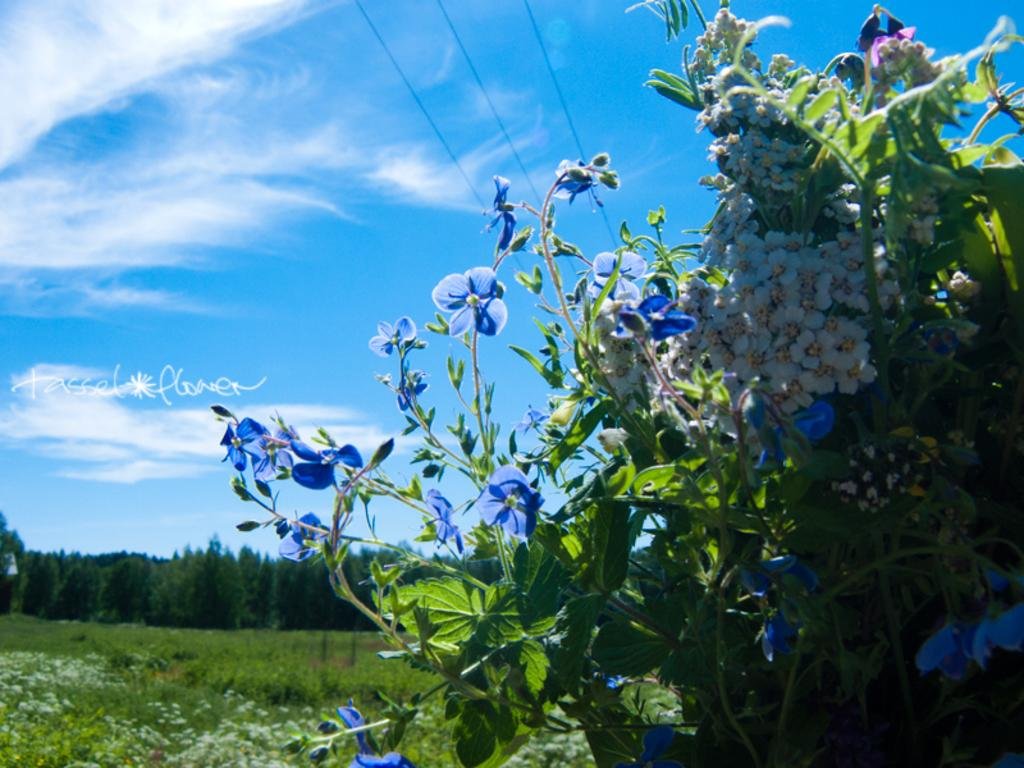What type of vegetation can be seen in the image? There are plants, trees, and grass in the image. Are there any flowers present in the image? Yes, there are flowers in the image. What can be seen at the top of the image? Power line cables and the sky are visible at the top of the image. Is there any text present in the image? Yes, there is text on the left side of the image. What type of art can be seen in the image? There is no art present in the image; it features plants, trees, grass, flowers, power line cables, the sky, and text. Is there any indication of death in the image? There is no indication of death in the image; it is it is a scene of vegetation and other elements. 